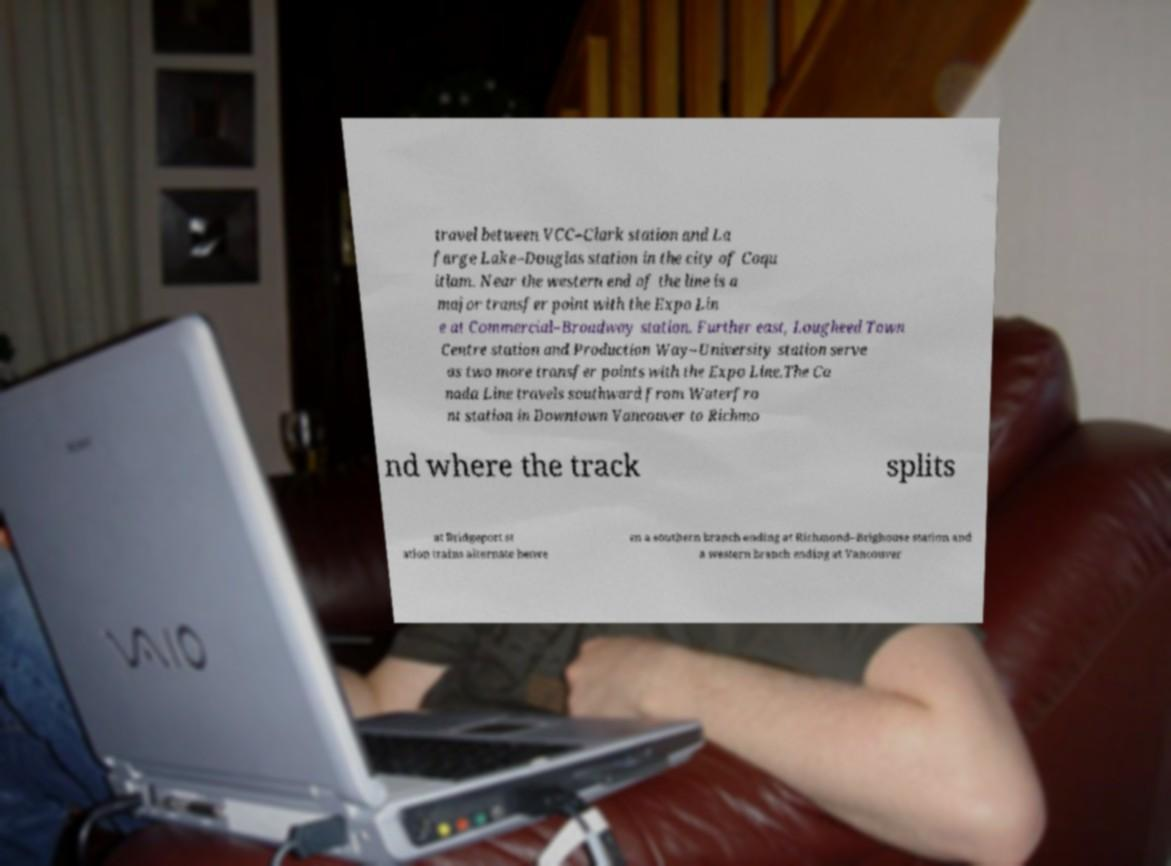There's text embedded in this image that I need extracted. Can you transcribe it verbatim? travel between VCC–Clark station and La farge Lake–Douglas station in the city of Coqu itlam. Near the western end of the line is a major transfer point with the Expo Lin e at Commercial–Broadway station. Further east, Lougheed Town Centre station and Production Way–University station serve as two more transfer points with the Expo Line.The Ca nada Line travels southward from Waterfro nt station in Downtown Vancouver to Richmo nd where the track splits at Bridgeport st ation trains alternate betwe en a southern branch ending at Richmond–Brighouse station and a western branch ending at Vancouver 